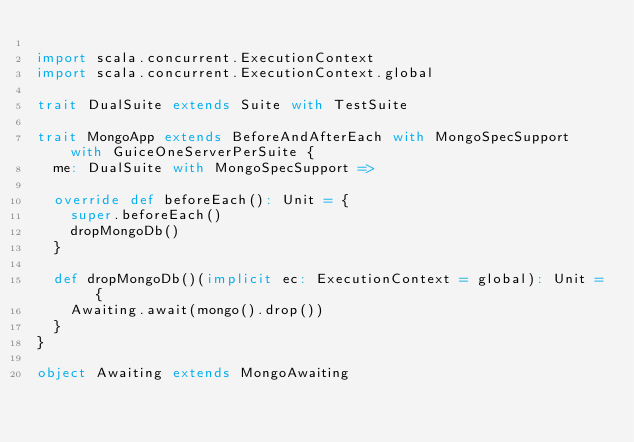<code> <loc_0><loc_0><loc_500><loc_500><_Scala_>
import scala.concurrent.ExecutionContext
import scala.concurrent.ExecutionContext.global

trait DualSuite extends Suite with TestSuite

trait MongoApp extends BeforeAndAfterEach with MongoSpecSupport with GuiceOneServerPerSuite {
  me: DualSuite with MongoSpecSupport =>

  override def beforeEach(): Unit = {
    super.beforeEach()
    dropMongoDb()
  }

  def dropMongoDb()(implicit ec: ExecutionContext = global): Unit = {
    Awaiting.await(mongo().drop())
  }
}

object Awaiting extends MongoAwaiting
</code> 